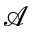Convert formula to latex. <formula><loc_0><loc_0><loc_500><loc_500>\mathcal { A }</formula> 